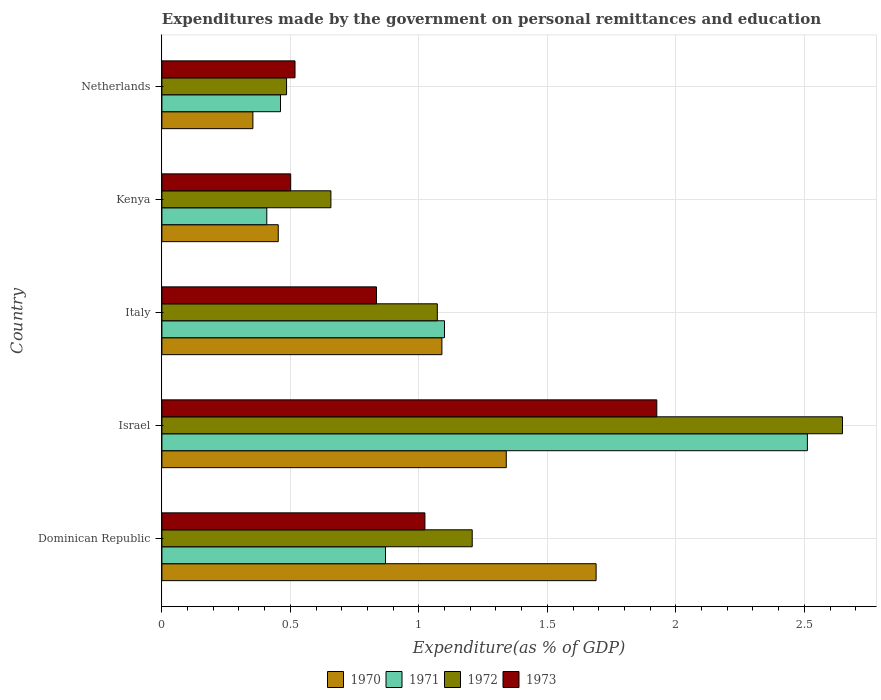How many groups of bars are there?
Give a very brief answer. 5. Are the number of bars per tick equal to the number of legend labels?
Your answer should be compact. Yes. Are the number of bars on each tick of the Y-axis equal?
Provide a succinct answer. Yes. How many bars are there on the 2nd tick from the top?
Your response must be concise. 4. How many bars are there on the 1st tick from the bottom?
Your answer should be compact. 4. What is the label of the 5th group of bars from the top?
Offer a very short reply. Dominican Republic. In how many cases, is the number of bars for a given country not equal to the number of legend labels?
Give a very brief answer. 0. What is the expenditures made by the government on personal remittances and education in 1971 in Kenya?
Keep it short and to the point. 0.41. Across all countries, what is the maximum expenditures made by the government on personal remittances and education in 1973?
Your answer should be very brief. 1.93. Across all countries, what is the minimum expenditures made by the government on personal remittances and education in 1970?
Your answer should be compact. 0.35. In which country was the expenditures made by the government on personal remittances and education in 1971 maximum?
Keep it short and to the point. Israel. In which country was the expenditures made by the government on personal remittances and education in 1973 minimum?
Provide a succinct answer. Kenya. What is the total expenditures made by the government on personal remittances and education in 1973 in the graph?
Offer a terse response. 4.8. What is the difference between the expenditures made by the government on personal remittances and education in 1972 in Italy and that in Kenya?
Give a very brief answer. 0.41. What is the difference between the expenditures made by the government on personal remittances and education in 1973 in Italy and the expenditures made by the government on personal remittances and education in 1972 in Netherlands?
Offer a very short reply. 0.35. What is the average expenditures made by the government on personal remittances and education in 1972 per country?
Your response must be concise. 1.21. What is the difference between the expenditures made by the government on personal remittances and education in 1971 and expenditures made by the government on personal remittances and education in 1973 in Italy?
Ensure brevity in your answer.  0.26. What is the ratio of the expenditures made by the government on personal remittances and education in 1972 in Israel to that in Kenya?
Keep it short and to the point. 4.03. What is the difference between the highest and the second highest expenditures made by the government on personal remittances and education in 1970?
Give a very brief answer. 0.35. What is the difference between the highest and the lowest expenditures made by the government on personal remittances and education in 1971?
Provide a succinct answer. 2.1. In how many countries, is the expenditures made by the government on personal remittances and education in 1970 greater than the average expenditures made by the government on personal remittances and education in 1970 taken over all countries?
Offer a very short reply. 3. Is the sum of the expenditures made by the government on personal remittances and education in 1973 in Dominican Republic and Netherlands greater than the maximum expenditures made by the government on personal remittances and education in 1971 across all countries?
Provide a short and direct response. No. Is it the case that in every country, the sum of the expenditures made by the government on personal remittances and education in 1972 and expenditures made by the government on personal remittances and education in 1970 is greater than the sum of expenditures made by the government on personal remittances and education in 1973 and expenditures made by the government on personal remittances and education in 1971?
Make the answer very short. No. What does the 2nd bar from the top in Netherlands represents?
Your answer should be very brief. 1972. Is it the case that in every country, the sum of the expenditures made by the government on personal remittances and education in 1973 and expenditures made by the government on personal remittances and education in 1972 is greater than the expenditures made by the government on personal remittances and education in 1970?
Offer a very short reply. Yes. Are all the bars in the graph horizontal?
Keep it short and to the point. Yes. How many countries are there in the graph?
Your answer should be compact. 5. What is the difference between two consecutive major ticks on the X-axis?
Keep it short and to the point. 0.5. Does the graph contain grids?
Ensure brevity in your answer.  Yes. Where does the legend appear in the graph?
Offer a very short reply. Bottom center. What is the title of the graph?
Give a very brief answer. Expenditures made by the government on personal remittances and education. Does "1981" appear as one of the legend labels in the graph?
Offer a very short reply. No. What is the label or title of the X-axis?
Keep it short and to the point. Expenditure(as % of GDP). What is the Expenditure(as % of GDP) in 1970 in Dominican Republic?
Offer a terse response. 1.69. What is the Expenditure(as % of GDP) in 1971 in Dominican Republic?
Ensure brevity in your answer.  0.87. What is the Expenditure(as % of GDP) of 1972 in Dominican Republic?
Provide a short and direct response. 1.21. What is the Expenditure(as % of GDP) in 1973 in Dominican Republic?
Your answer should be very brief. 1.02. What is the Expenditure(as % of GDP) in 1970 in Israel?
Provide a succinct answer. 1.34. What is the Expenditure(as % of GDP) in 1971 in Israel?
Your answer should be compact. 2.51. What is the Expenditure(as % of GDP) in 1972 in Israel?
Provide a short and direct response. 2.65. What is the Expenditure(as % of GDP) of 1973 in Israel?
Your answer should be very brief. 1.93. What is the Expenditure(as % of GDP) of 1970 in Italy?
Give a very brief answer. 1.09. What is the Expenditure(as % of GDP) in 1971 in Italy?
Make the answer very short. 1.1. What is the Expenditure(as % of GDP) in 1972 in Italy?
Your answer should be compact. 1.07. What is the Expenditure(as % of GDP) of 1973 in Italy?
Offer a terse response. 0.84. What is the Expenditure(as % of GDP) in 1970 in Kenya?
Keep it short and to the point. 0.45. What is the Expenditure(as % of GDP) of 1971 in Kenya?
Keep it short and to the point. 0.41. What is the Expenditure(as % of GDP) in 1972 in Kenya?
Make the answer very short. 0.66. What is the Expenditure(as % of GDP) in 1973 in Kenya?
Keep it short and to the point. 0.5. What is the Expenditure(as % of GDP) in 1970 in Netherlands?
Ensure brevity in your answer.  0.35. What is the Expenditure(as % of GDP) of 1971 in Netherlands?
Ensure brevity in your answer.  0.46. What is the Expenditure(as % of GDP) in 1972 in Netherlands?
Make the answer very short. 0.49. What is the Expenditure(as % of GDP) of 1973 in Netherlands?
Your answer should be very brief. 0.52. Across all countries, what is the maximum Expenditure(as % of GDP) in 1970?
Offer a terse response. 1.69. Across all countries, what is the maximum Expenditure(as % of GDP) in 1971?
Provide a short and direct response. 2.51. Across all countries, what is the maximum Expenditure(as % of GDP) in 1972?
Your response must be concise. 2.65. Across all countries, what is the maximum Expenditure(as % of GDP) in 1973?
Your response must be concise. 1.93. Across all countries, what is the minimum Expenditure(as % of GDP) of 1970?
Ensure brevity in your answer.  0.35. Across all countries, what is the minimum Expenditure(as % of GDP) in 1971?
Offer a very short reply. 0.41. Across all countries, what is the minimum Expenditure(as % of GDP) in 1972?
Keep it short and to the point. 0.49. Across all countries, what is the minimum Expenditure(as % of GDP) in 1973?
Your response must be concise. 0.5. What is the total Expenditure(as % of GDP) in 1970 in the graph?
Give a very brief answer. 4.93. What is the total Expenditure(as % of GDP) of 1971 in the graph?
Give a very brief answer. 5.35. What is the total Expenditure(as % of GDP) in 1972 in the graph?
Ensure brevity in your answer.  6.07. What is the total Expenditure(as % of GDP) of 1973 in the graph?
Provide a short and direct response. 4.8. What is the difference between the Expenditure(as % of GDP) of 1970 in Dominican Republic and that in Israel?
Ensure brevity in your answer.  0.35. What is the difference between the Expenditure(as % of GDP) in 1971 in Dominican Republic and that in Israel?
Your answer should be very brief. -1.64. What is the difference between the Expenditure(as % of GDP) of 1972 in Dominican Republic and that in Israel?
Give a very brief answer. -1.44. What is the difference between the Expenditure(as % of GDP) in 1973 in Dominican Republic and that in Israel?
Your answer should be compact. -0.9. What is the difference between the Expenditure(as % of GDP) in 1970 in Dominican Republic and that in Italy?
Offer a terse response. 0.6. What is the difference between the Expenditure(as % of GDP) in 1971 in Dominican Republic and that in Italy?
Ensure brevity in your answer.  -0.23. What is the difference between the Expenditure(as % of GDP) in 1972 in Dominican Republic and that in Italy?
Give a very brief answer. 0.14. What is the difference between the Expenditure(as % of GDP) in 1973 in Dominican Republic and that in Italy?
Your response must be concise. 0.19. What is the difference between the Expenditure(as % of GDP) of 1970 in Dominican Republic and that in Kenya?
Ensure brevity in your answer.  1.24. What is the difference between the Expenditure(as % of GDP) in 1971 in Dominican Republic and that in Kenya?
Give a very brief answer. 0.46. What is the difference between the Expenditure(as % of GDP) in 1972 in Dominican Republic and that in Kenya?
Ensure brevity in your answer.  0.55. What is the difference between the Expenditure(as % of GDP) of 1973 in Dominican Republic and that in Kenya?
Offer a terse response. 0.52. What is the difference between the Expenditure(as % of GDP) in 1970 in Dominican Republic and that in Netherlands?
Make the answer very short. 1.34. What is the difference between the Expenditure(as % of GDP) in 1971 in Dominican Republic and that in Netherlands?
Make the answer very short. 0.41. What is the difference between the Expenditure(as % of GDP) in 1972 in Dominican Republic and that in Netherlands?
Provide a short and direct response. 0.72. What is the difference between the Expenditure(as % of GDP) in 1973 in Dominican Republic and that in Netherlands?
Provide a succinct answer. 0.51. What is the difference between the Expenditure(as % of GDP) of 1970 in Israel and that in Italy?
Make the answer very short. 0.25. What is the difference between the Expenditure(as % of GDP) of 1971 in Israel and that in Italy?
Give a very brief answer. 1.41. What is the difference between the Expenditure(as % of GDP) in 1972 in Israel and that in Italy?
Keep it short and to the point. 1.58. What is the difference between the Expenditure(as % of GDP) of 1973 in Israel and that in Italy?
Make the answer very short. 1.09. What is the difference between the Expenditure(as % of GDP) in 1970 in Israel and that in Kenya?
Your answer should be compact. 0.89. What is the difference between the Expenditure(as % of GDP) in 1971 in Israel and that in Kenya?
Give a very brief answer. 2.1. What is the difference between the Expenditure(as % of GDP) in 1972 in Israel and that in Kenya?
Offer a very short reply. 1.99. What is the difference between the Expenditure(as % of GDP) in 1973 in Israel and that in Kenya?
Provide a succinct answer. 1.42. What is the difference between the Expenditure(as % of GDP) of 1970 in Israel and that in Netherlands?
Provide a short and direct response. 0.99. What is the difference between the Expenditure(as % of GDP) of 1971 in Israel and that in Netherlands?
Your answer should be compact. 2.05. What is the difference between the Expenditure(as % of GDP) of 1972 in Israel and that in Netherlands?
Provide a succinct answer. 2.16. What is the difference between the Expenditure(as % of GDP) of 1973 in Israel and that in Netherlands?
Offer a very short reply. 1.41. What is the difference between the Expenditure(as % of GDP) of 1970 in Italy and that in Kenya?
Keep it short and to the point. 0.64. What is the difference between the Expenditure(as % of GDP) in 1971 in Italy and that in Kenya?
Your answer should be very brief. 0.69. What is the difference between the Expenditure(as % of GDP) in 1972 in Italy and that in Kenya?
Ensure brevity in your answer.  0.41. What is the difference between the Expenditure(as % of GDP) in 1973 in Italy and that in Kenya?
Give a very brief answer. 0.33. What is the difference between the Expenditure(as % of GDP) in 1970 in Italy and that in Netherlands?
Keep it short and to the point. 0.74. What is the difference between the Expenditure(as % of GDP) of 1971 in Italy and that in Netherlands?
Give a very brief answer. 0.64. What is the difference between the Expenditure(as % of GDP) in 1972 in Italy and that in Netherlands?
Provide a short and direct response. 0.59. What is the difference between the Expenditure(as % of GDP) of 1973 in Italy and that in Netherlands?
Your answer should be very brief. 0.32. What is the difference between the Expenditure(as % of GDP) of 1970 in Kenya and that in Netherlands?
Give a very brief answer. 0.1. What is the difference between the Expenditure(as % of GDP) in 1971 in Kenya and that in Netherlands?
Provide a succinct answer. -0.05. What is the difference between the Expenditure(as % of GDP) in 1972 in Kenya and that in Netherlands?
Your response must be concise. 0.17. What is the difference between the Expenditure(as % of GDP) of 1973 in Kenya and that in Netherlands?
Offer a very short reply. -0.02. What is the difference between the Expenditure(as % of GDP) of 1970 in Dominican Republic and the Expenditure(as % of GDP) of 1971 in Israel?
Provide a short and direct response. -0.82. What is the difference between the Expenditure(as % of GDP) of 1970 in Dominican Republic and the Expenditure(as % of GDP) of 1972 in Israel?
Make the answer very short. -0.96. What is the difference between the Expenditure(as % of GDP) of 1970 in Dominican Republic and the Expenditure(as % of GDP) of 1973 in Israel?
Your answer should be compact. -0.24. What is the difference between the Expenditure(as % of GDP) of 1971 in Dominican Republic and the Expenditure(as % of GDP) of 1972 in Israel?
Give a very brief answer. -1.78. What is the difference between the Expenditure(as % of GDP) of 1971 in Dominican Republic and the Expenditure(as % of GDP) of 1973 in Israel?
Keep it short and to the point. -1.06. What is the difference between the Expenditure(as % of GDP) of 1972 in Dominican Republic and the Expenditure(as % of GDP) of 1973 in Israel?
Keep it short and to the point. -0.72. What is the difference between the Expenditure(as % of GDP) of 1970 in Dominican Republic and the Expenditure(as % of GDP) of 1971 in Italy?
Make the answer very short. 0.59. What is the difference between the Expenditure(as % of GDP) in 1970 in Dominican Republic and the Expenditure(as % of GDP) in 1972 in Italy?
Your response must be concise. 0.62. What is the difference between the Expenditure(as % of GDP) in 1970 in Dominican Republic and the Expenditure(as % of GDP) in 1973 in Italy?
Make the answer very short. 0.85. What is the difference between the Expenditure(as % of GDP) in 1971 in Dominican Republic and the Expenditure(as % of GDP) in 1972 in Italy?
Your answer should be compact. -0.2. What is the difference between the Expenditure(as % of GDP) of 1971 in Dominican Republic and the Expenditure(as % of GDP) of 1973 in Italy?
Ensure brevity in your answer.  0.04. What is the difference between the Expenditure(as % of GDP) of 1972 in Dominican Republic and the Expenditure(as % of GDP) of 1973 in Italy?
Your answer should be very brief. 0.37. What is the difference between the Expenditure(as % of GDP) in 1970 in Dominican Republic and the Expenditure(as % of GDP) in 1971 in Kenya?
Ensure brevity in your answer.  1.28. What is the difference between the Expenditure(as % of GDP) of 1970 in Dominican Republic and the Expenditure(as % of GDP) of 1972 in Kenya?
Your answer should be very brief. 1.03. What is the difference between the Expenditure(as % of GDP) of 1970 in Dominican Republic and the Expenditure(as % of GDP) of 1973 in Kenya?
Your response must be concise. 1.19. What is the difference between the Expenditure(as % of GDP) of 1971 in Dominican Republic and the Expenditure(as % of GDP) of 1972 in Kenya?
Give a very brief answer. 0.21. What is the difference between the Expenditure(as % of GDP) of 1971 in Dominican Republic and the Expenditure(as % of GDP) of 1973 in Kenya?
Offer a terse response. 0.37. What is the difference between the Expenditure(as % of GDP) in 1972 in Dominican Republic and the Expenditure(as % of GDP) in 1973 in Kenya?
Your answer should be compact. 0.71. What is the difference between the Expenditure(as % of GDP) in 1970 in Dominican Republic and the Expenditure(as % of GDP) in 1971 in Netherlands?
Your answer should be very brief. 1.23. What is the difference between the Expenditure(as % of GDP) in 1970 in Dominican Republic and the Expenditure(as % of GDP) in 1972 in Netherlands?
Provide a short and direct response. 1.2. What is the difference between the Expenditure(as % of GDP) of 1970 in Dominican Republic and the Expenditure(as % of GDP) of 1973 in Netherlands?
Your response must be concise. 1.17. What is the difference between the Expenditure(as % of GDP) of 1971 in Dominican Republic and the Expenditure(as % of GDP) of 1972 in Netherlands?
Your answer should be very brief. 0.39. What is the difference between the Expenditure(as % of GDP) of 1971 in Dominican Republic and the Expenditure(as % of GDP) of 1973 in Netherlands?
Offer a very short reply. 0.35. What is the difference between the Expenditure(as % of GDP) of 1972 in Dominican Republic and the Expenditure(as % of GDP) of 1973 in Netherlands?
Your answer should be compact. 0.69. What is the difference between the Expenditure(as % of GDP) in 1970 in Israel and the Expenditure(as % of GDP) in 1971 in Italy?
Make the answer very short. 0.24. What is the difference between the Expenditure(as % of GDP) of 1970 in Israel and the Expenditure(as % of GDP) of 1972 in Italy?
Give a very brief answer. 0.27. What is the difference between the Expenditure(as % of GDP) of 1970 in Israel and the Expenditure(as % of GDP) of 1973 in Italy?
Keep it short and to the point. 0.51. What is the difference between the Expenditure(as % of GDP) of 1971 in Israel and the Expenditure(as % of GDP) of 1972 in Italy?
Provide a short and direct response. 1.44. What is the difference between the Expenditure(as % of GDP) in 1971 in Israel and the Expenditure(as % of GDP) in 1973 in Italy?
Ensure brevity in your answer.  1.68. What is the difference between the Expenditure(as % of GDP) in 1972 in Israel and the Expenditure(as % of GDP) in 1973 in Italy?
Ensure brevity in your answer.  1.81. What is the difference between the Expenditure(as % of GDP) of 1970 in Israel and the Expenditure(as % of GDP) of 1971 in Kenya?
Your response must be concise. 0.93. What is the difference between the Expenditure(as % of GDP) of 1970 in Israel and the Expenditure(as % of GDP) of 1972 in Kenya?
Provide a succinct answer. 0.68. What is the difference between the Expenditure(as % of GDP) of 1970 in Israel and the Expenditure(as % of GDP) of 1973 in Kenya?
Your response must be concise. 0.84. What is the difference between the Expenditure(as % of GDP) in 1971 in Israel and the Expenditure(as % of GDP) in 1972 in Kenya?
Provide a succinct answer. 1.85. What is the difference between the Expenditure(as % of GDP) of 1971 in Israel and the Expenditure(as % of GDP) of 1973 in Kenya?
Provide a short and direct response. 2.01. What is the difference between the Expenditure(as % of GDP) in 1972 in Israel and the Expenditure(as % of GDP) in 1973 in Kenya?
Offer a terse response. 2.15. What is the difference between the Expenditure(as % of GDP) of 1970 in Israel and the Expenditure(as % of GDP) of 1971 in Netherlands?
Ensure brevity in your answer.  0.88. What is the difference between the Expenditure(as % of GDP) of 1970 in Israel and the Expenditure(as % of GDP) of 1972 in Netherlands?
Your answer should be compact. 0.85. What is the difference between the Expenditure(as % of GDP) of 1970 in Israel and the Expenditure(as % of GDP) of 1973 in Netherlands?
Offer a terse response. 0.82. What is the difference between the Expenditure(as % of GDP) in 1971 in Israel and the Expenditure(as % of GDP) in 1972 in Netherlands?
Provide a succinct answer. 2.03. What is the difference between the Expenditure(as % of GDP) of 1971 in Israel and the Expenditure(as % of GDP) of 1973 in Netherlands?
Offer a very short reply. 1.99. What is the difference between the Expenditure(as % of GDP) of 1972 in Israel and the Expenditure(as % of GDP) of 1973 in Netherlands?
Your answer should be very brief. 2.13. What is the difference between the Expenditure(as % of GDP) of 1970 in Italy and the Expenditure(as % of GDP) of 1971 in Kenya?
Offer a very short reply. 0.68. What is the difference between the Expenditure(as % of GDP) in 1970 in Italy and the Expenditure(as % of GDP) in 1972 in Kenya?
Give a very brief answer. 0.43. What is the difference between the Expenditure(as % of GDP) of 1970 in Italy and the Expenditure(as % of GDP) of 1973 in Kenya?
Offer a terse response. 0.59. What is the difference between the Expenditure(as % of GDP) of 1971 in Italy and the Expenditure(as % of GDP) of 1972 in Kenya?
Ensure brevity in your answer.  0.44. What is the difference between the Expenditure(as % of GDP) in 1971 in Italy and the Expenditure(as % of GDP) in 1973 in Kenya?
Keep it short and to the point. 0.6. What is the difference between the Expenditure(as % of GDP) of 1972 in Italy and the Expenditure(as % of GDP) of 1973 in Kenya?
Offer a terse response. 0.57. What is the difference between the Expenditure(as % of GDP) in 1970 in Italy and the Expenditure(as % of GDP) in 1971 in Netherlands?
Ensure brevity in your answer.  0.63. What is the difference between the Expenditure(as % of GDP) of 1970 in Italy and the Expenditure(as % of GDP) of 1972 in Netherlands?
Your answer should be compact. 0.6. What is the difference between the Expenditure(as % of GDP) of 1970 in Italy and the Expenditure(as % of GDP) of 1973 in Netherlands?
Your response must be concise. 0.57. What is the difference between the Expenditure(as % of GDP) of 1971 in Italy and the Expenditure(as % of GDP) of 1972 in Netherlands?
Offer a terse response. 0.61. What is the difference between the Expenditure(as % of GDP) of 1971 in Italy and the Expenditure(as % of GDP) of 1973 in Netherlands?
Your answer should be compact. 0.58. What is the difference between the Expenditure(as % of GDP) of 1972 in Italy and the Expenditure(as % of GDP) of 1973 in Netherlands?
Keep it short and to the point. 0.55. What is the difference between the Expenditure(as % of GDP) in 1970 in Kenya and the Expenditure(as % of GDP) in 1971 in Netherlands?
Your answer should be compact. -0.01. What is the difference between the Expenditure(as % of GDP) in 1970 in Kenya and the Expenditure(as % of GDP) in 1972 in Netherlands?
Give a very brief answer. -0.03. What is the difference between the Expenditure(as % of GDP) of 1970 in Kenya and the Expenditure(as % of GDP) of 1973 in Netherlands?
Offer a very short reply. -0.07. What is the difference between the Expenditure(as % of GDP) in 1971 in Kenya and the Expenditure(as % of GDP) in 1972 in Netherlands?
Your answer should be compact. -0.08. What is the difference between the Expenditure(as % of GDP) in 1971 in Kenya and the Expenditure(as % of GDP) in 1973 in Netherlands?
Offer a very short reply. -0.11. What is the difference between the Expenditure(as % of GDP) of 1972 in Kenya and the Expenditure(as % of GDP) of 1973 in Netherlands?
Offer a terse response. 0.14. What is the average Expenditure(as % of GDP) in 1971 per country?
Ensure brevity in your answer.  1.07. What is the average Expenditure(as % of GDP) in 1972 per country?
Your response must be concise. 1.21. What is the average Expenditure(as % of GDP) in 1973 per country?
Provide a short and direct response. 0.96. What is the difference between the Expenditure(as % of GDP) of 1970 and Expenditure(as % of GDP) of 1971 in Dominican Republic?
Your answer should be very brief. 0.82. What is the difference between the Expenditure(as % of GDP) in 1970 and Expenditure(as % of GDP) in 1972 in Dominican Republic?
Keep it short and to the point. 0.48. What is the difference between the Expenditure(as % of GDP) of 1970 and Expenditure(as % of GDP) of 1973 in Dominican Republic?
Your answer should be compact. 0.67. What is the difference between the Expenditure(as % of GDP) of 1971 and Expenditure(as % of GDP) of 1972 in Dominican Republic?
Make the answer very short. -0.34. What is the difference between the Expenditure(as % of GDP) of 1971 and Expenditure(as % of GDP) of 1973 in Dominican Republic?
Give a very brief answer. -0.15. What is the difference between the Expenditure(as % of GDP) of 1972 and Expenditure(as % of GDP) of 1973 in Dominican Republic?
Make the answer very short. 0.18. What is the difference between the Expenditure(as % of GDP) of 1970 and Expenditure(as % of GDP) of 1971 in Israel?
Your answer should be very brief. -1.17. What is the difference between the Expenditure(as % of GDP) of 1970 and Expenditure(as % of GDP) of 1972 in Israel?
Your response must be concise. -1.31. What is the difference between the Expenditure(as % of GDP) of 1970 and Expenditure(as % of GDP) of 1973 in Israel?
Make the answer very short. -0.59. What is the difference between the Expenditure(as % of GDP) of 1971 and Expenditure(as % of GDP) of 1972 in Israel?
Provide a succinct answer. -0.14. What is the difference between the Expenditure(as % of GDP) in 1971 and Expenditure(as % of GDP) in 1973 in Israel?
Give a very brief answer. 0.59. What is the difference between the Expenditure(as % of GDP) of 1972 and Expenditure(as % of GDP) of 1973 in Israel?
Offer a very short reply. 0.72. What is the difference between the Expenditure(as % of GDP) in 1970 and Expenditure(as % of GDP) in 1971 in Italy?
Provide a short and direct response. -0.01. What is the difference between the Expenditure(as % of GDP) of 1970 and Expenditure(as % of GDP) of 1972 in Italy?
Provide a succinct answer. 0.02. What is the difference between the Expenditure(as % of GDP) in 1970 and Expenditure(as % of GDP) in 1973 in Italy?
Keep it short and to the point. 0.25. What is the difference between the Expenditure(as % of GDP) in 1971 and Expenditure(as % of GDP) in 1972 in Italy?
Your answer should be compact. 0.03. What is the difference between the Expenditure(as % of GDP) in 1971 and Expenditure(as % of GDP) in 1973 in Italy?
Give a very brief answer. 0.26. What is the difference between the Expenditure(as % of GDP) of 1972 and Expenditure(as % of GDP) of 1973 in Italy?
Provide a short and direct response. 0.24. What is the difference between the Expenditure(as % of GDP) of 1970 and Expenditure(as % of GDP) of 1971 in Kenya?
Provide a succinct answer. 0.04. What is the difference between the Expenditure(as % of GDP) in 1970 and Expenditure(as % of GDP) in 1972 in Kenya?
Your answer should be very brief. -0.2. What is the difference between the Expenditure(as % of GDP) of 1970 and Expenditure(as % of GDP) of 1973 in Kenya?
Your answer should be very brief. -0.05. What is the difference between the Expenditure(as % of GDP) in 1971 and Expenditure(as % of GDP) in 1972 in Kenya?
Your answer should be compact. -0.25. What is the difference between the Expenditure(as % of GDP) of 1971 and Expenditure(as % of GDP) of 1973 in Kenya?
Offer a terse response. -0.09. What is the difference between the Expenditure(as % of GDP) of 1972 and Expenditure(as % of GDP) of 1973 in Kenya?
Give a very brief answer. 0.16. What is the difference between the Expenditure(as % of GDP) of 1970 and Expenditure(as % of GDP) of 1971 in Netherlands?
Your response must be concise. -0.11. What is the difference between the Expenditure(as % of GDP) of 1970 and Expenditure(as % of GDP) of 1972 in Netherlands?
Your response must be concise. -0.13. What is the difference between the Expenditure(as % of GDP) of 1970 and Expenditure(as % of GDP) of 1973 in Netherlands?
Provide a succinct answer. -0.16. What is the difference between the Expenditure(as % of GDP) in 1971 and Expenditure(as % of GDP) in 1972 in Netherlands?
Provide a short and direct response. -0.02. What is the difference between the Expenditure(as % of GDP) of 1971 and Expenditure(as % of GDP) of 1973 in Netherlands?
Your answer should be very brief. -0.06. What is the difference between the Expenditure(as % of GDP) in 1972 and Expenditure(as % of GDP) in 1973 in Netherlands?
Keep it short and to the point. -0.03. What is the ratio of the Expenditure(as % of GDP) of 1970 in Dominican Republic to that in Israel?
Your answer should be compact. 1.26. What is the ratio of the Expenditure(as % of GDP) of 1971 in Dominican Republic to that in Israel?
Offer a terse response. 0.35. What is the ratio of the Expenditure(as % of GDP) in 1972 in Dominican Republic to that in Israel?
Ensure brevity in your answer.  0.46. What is the ratio of the Expenditure(as % of GDP) of 1973 in Dominican Republic to that in Israel?
Keep it short and to the point. 0.53. What is the ratio of the Expenditure(as % of GDP) of 1970 in Dominican Republic to that in Italy?
Offer a terse response. 1.55. What is the ratio of the Expenditure(as % of GDP) in 1971 in Dominican Republic to that in Italy?
Your response must be concise. 0.79. What is the ratio of the Expenditure(as % of GDP) in 1972 in Dominican Republic to that in Italy?
Give a very brief answer. 1.13. What is the ratio of the Expenditure(as % of GDP) in 1973 in Dominican Republic to that in Italy?
Your answer should be very brief. 1.23. What is the ratio of the Expenditure(as % of GDP) of 1970 in Dominican Republic to that in Kenya?
Offer a very short reply. 3.73. What is the ratio of the Expenditure(as % of GDP) in 1971 in Dominican Republic to that in Kenya?
Make the answer very short. 2.13. What is the ratio of the Expenditure(as % of GDP) in 1972 in Dominican Republic to that in Kenya?
Your response must be concise. 1.84. What is the ratio of the Expenditure(as % of GDP) in 1973 in Dominican Republic to that in Kenya?
Offer a terse response. 2.04. What is the ratio of the Expenditure(as % of GDP) of 1970 in Dominican Republic to that in Netherlands?
Give a very brief answer. 4.77. What is the ratio of the Expenditure(as % of GDP) in 1971 in Dominican Republic to that in Netherlands?
Offer a terse response. 1.89. What is the ratio of the Expenditure(as % of GDP) of 1972 in Dominican Republic to that in Netherlands?
Provide a succinct answer. 2.49. What is the ratio of the Expenditure(as % of GDP) in 1973 in Dominican Republic to that in Netherlands?
Keep it short and to the point. 1.98. What is the ratio of the Expenditure(as % of GDP) in 1970 in Israel to that in Italy?
Offer a terse response. 1.23. What is the ratio of the Expenditure(as % of GDP) in 1971 in Israel to that in Italy?
Give a very brief answer. 2.28. What is the ratio of the Expenditure(as % of GDP) of 1972 in Israel to that in Italy?
Your answer should be compact. 2.47. What is the ratio of the Expenditure(as % of GDP) of 1973 in Israel to that in Italy?
Make the answer very short. 2.31. What is the ratio of the Expenditure(as % of GDP) in 1970 in Israel to that in Kenya?
Offer a terse response. 2.96. What is the ratio of the Expenditure(as % of GDP) of 1971 in Israel to that in Kenya?
Give a very brief answer. 6.15. What is the ratio of the Expenditure(as % of GDP) in 1972 in Israel to that in Kenya?
Give a very brief answer. 4.03. What is the ratio of the Expenditure(as % of GDP) of 1973 in Israel to that in Kenya?
Your response must be concise. 3.84. What is the ratio of the Expenditure(as % of GDP) of 1970 in Israel to that in Netherlands?
Keep it short and to the point. 3.78. What is the ratio of the Expenditure(as % of GDP) in 1971 in Israel to that in Netherlands?
Offer a terse response. 5.44. What is the ratio of the Expenditure(as % of GDP) of 1972 in Israel to that in Netherlands?
Provide a succinct answer. 5.46. What is the ratio of the Expenditure(as % of GDP) in 1973 in Israel to that in Netherlands?
Provide a succinct answer. 3.72. What is the ratio of the Expenditure(as % of GDP) in 1970 in Italy to that in Kenya?
Keep it short and to the point. 2.41. What is the ratio of the Expenditure(as % of GDP) of 1971 in Italy to that in Kenya?
Offer a very short reply. 2.69. What is the ratio of the Expenditure(as % of GDP) of 1972 in Italy to that in Kenya?
Give a very brief answer. 1.63. What is the ratio of the Expenditure(as % of GDP) in 1973 in Italy to that in Kenya?
Provide a short and direct response. 1.67. What is the ratio of the Expenditure(as % of GDP) in 1970 in Italy to that in Netherlands?
Offer a terse response. 3.08. What is the ratio of the Expenditure(as % of GDP) of 1971 in Italy to that in Netherlands?
Your answer should be compact. 2.38. What is the ratio of the Expenditure(as % of GDP) of 1972 in Italy to that in Netherlands?
Keep it short and to the point. 2.21. What is the ratio of the Expenditure(as % of GDP) of 1973 in Italy to that in Netherlands?
Provide a short and direct response. 1.61. What is the ratio of the Expenditure(as % of GDP) of 1970 in Kenya to that in Netherlands?
Keep it short and to the point. 1.28. What is the ratio of the Expenditure(as % of GDP) of 1971 in Kenya to that in Netherlands?
Keep it short and to the point. 0.88. What is the ratio of the Expenditure(as % of GDP) of 1972 in Kenya to that in Netherlands?
Provide a short and direct response. 1.36. What is the ratio of the Expenditure(as % of GDP) in 1973 in Kenya to that in Netherlands?
Offer a terse response. 0.97. What is the difference between the highest and the second highest Expenditure(as % of GDP) in 1970?
Make the answer very short. 0.35. What is the difference between the highest and the second highest Expenditure(as % of GDP) of 1971?
Ensure brevity in your answer.  1.41. What is the difference between the highest and the second highest Expenditure(as % of GDP) of 1972?
Your answer should be compact. 1.44. What is the difference between the highest and the second highest Expenditure(as % of GDP) of 1973?
Give a very brief answer. 0.9. What is the difference between the highest and the lowest Expenditure(as % of GDP) of 1970?
Make the answer very short. 1.34. What is the difference between the highest and the lowest Expenditure(as % of GDP) in 1971?
Provide a succinct answer. 2.1. What is the difference between the highest and the lowest Expenditure(as % of GDP) in 1972?
Offer a terse response. 2.16. What is the difference between the highest and the lowest Expenditure(as % of GDP) in 1973?
Your response must be concise. 1.42. 